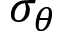Convert formula to latex. <formula><loc_0><loc_0><loc_500><loc_500>\sigma _ { \theta }</formula> 